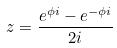Convert formula to latex. <formula><loc_0><loc_0><loc_500><loc_500>z = \frac { e ^ { \phi i } - e ^ { - \phi i } } { 2 i }</formula> 